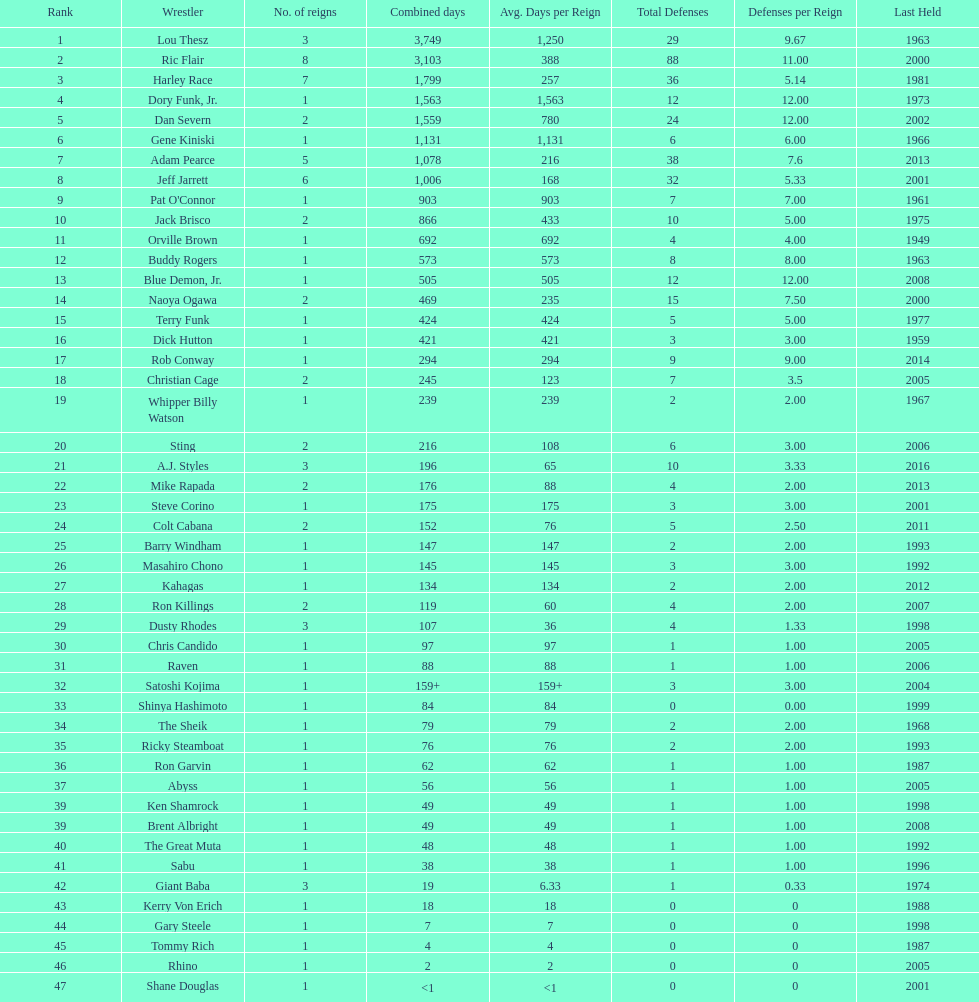Who has spent more time as nwa world heavyyweight champion, gene kiniski or ric flair? Ric Flair. 